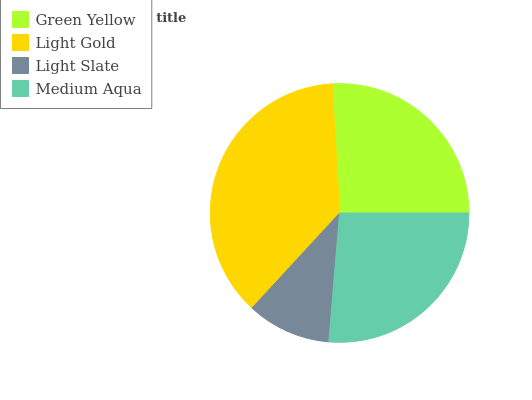Is Light Slate the minimum?
Answer yes or no. Yes. Is Light Gold the maximum?
Answer yes or no. Yes. Is Light Gold the minimum?
Answer yes or no. No. Is Light Slate the maximum?
Answer yes or no. No. Is Light Gold greater than Light Slate?
Answer yes or no. Yes. Is Light Slate less than Light Gold?
Answer yes or no. Yes. Is Light Slate greater than Light Gold?
Answer yes or no. No. Is Light Gold less than Light Slate?
Answer yes or no. No. Is Medium Aqua the high median?
Answer yes or no. Yes. Is Green Yellow the low median?
Answer yes or no. Yes. Is Light Gold the high median?
Answer yes or no. No. Is Light Gold the low median?
Answer yes or no. No. 